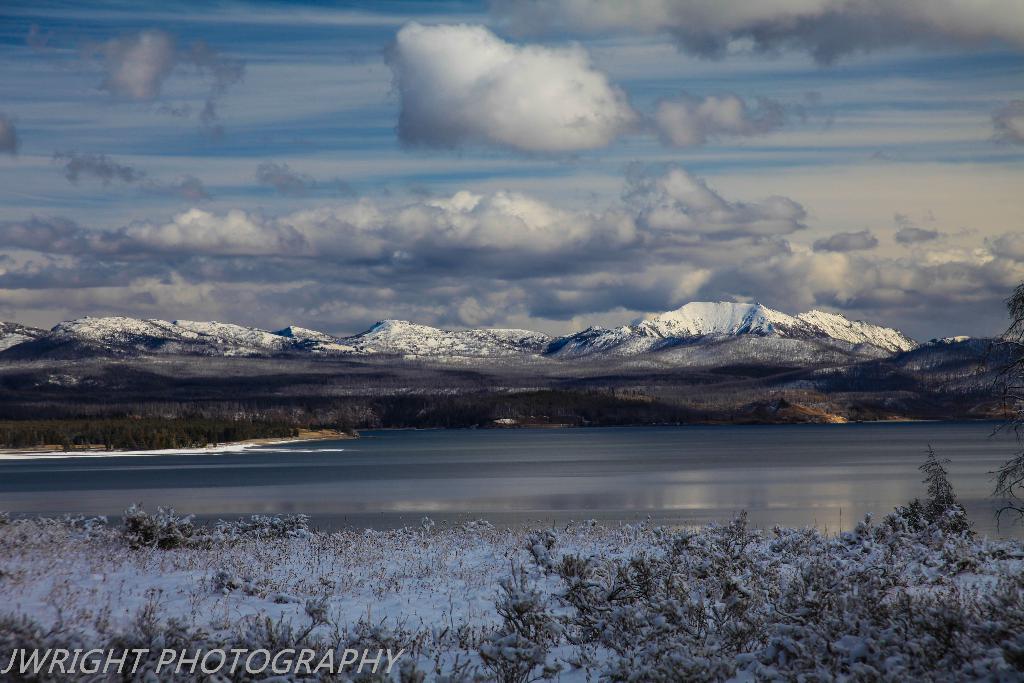Describe this image in one or two sentences. In this image, in the middle there are mountains, plants, water, ice, sky and clouds. At the bottom there is a text. 